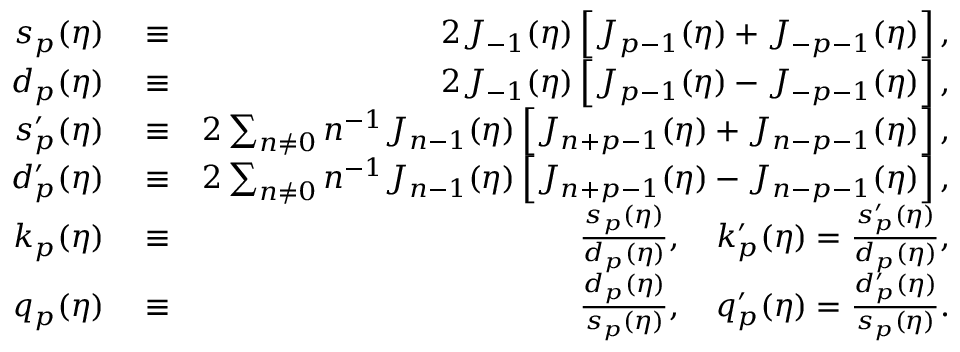Convert formula to latex. <formula><loc_0><loc_0><loc_500><loc_500>\begin{array} { r l r } { s _ { p } ( \eta ) } & \equiv } & { 2 J _ { - 1 } ( \eta ) \left [ J _ { p - 1 } ( \eta ) + J _ { - p - 1 } ( \eta ) \right ] , } \\ { d _ { p } ( \eta ) } & \equiv } & { 2 J _ { - 1 } ( \eta ) \left [ J _ { p - 1 } ( \eta ) - J _ { - p - 1 } ( \eta ) \right ] , } \\ { s _ { p } ^ { \prime } ( \eta ) } & \equiv } & { 2 \sum _ { n \neq 0 } n ^ { - 1 } J _ { n - 1 } ( \eta ) \left [ J _ { n + p - 1 } ( \eta ) + J _ { n - p - 1 } ( \eta ) \right ] , } \\ { d _ { p } ^ { \prime } ( \eta ) } & \equiv } & { 2 \sum _ { n \neq 0 } n ^ { - 1 } J _ { n - 1 } ( \eta ) \left [ J _ { n + p - 1 } ( \eta ) - J _ { n - p - 1 } ( \eta ) \right ] , } \\ { k _ { p } ( \eta ) } & \equiv } & { \frac { s _ { p } ( \eta ) } { d _ { p } ( \eta ) } , \quad k _ { p } ^ { \prime } ( \eta ) = \frac { s _ { p } ^ { \prime } ( \eta ) } { d _ { p } ( \eta ) } , } \\ { q _ { p } ( \eta ) } & \equiv } & { \frac { d _ { p } ( \eta ) } { s _ { p } ( \eta ) } , \quad q _ { p } ^ { \prime } ( \eta ) = \frac { d _ { p } ^ { \prime } ( \eta ) } { s _ { p } ( \eta ) } . } \end{array}</formula> 